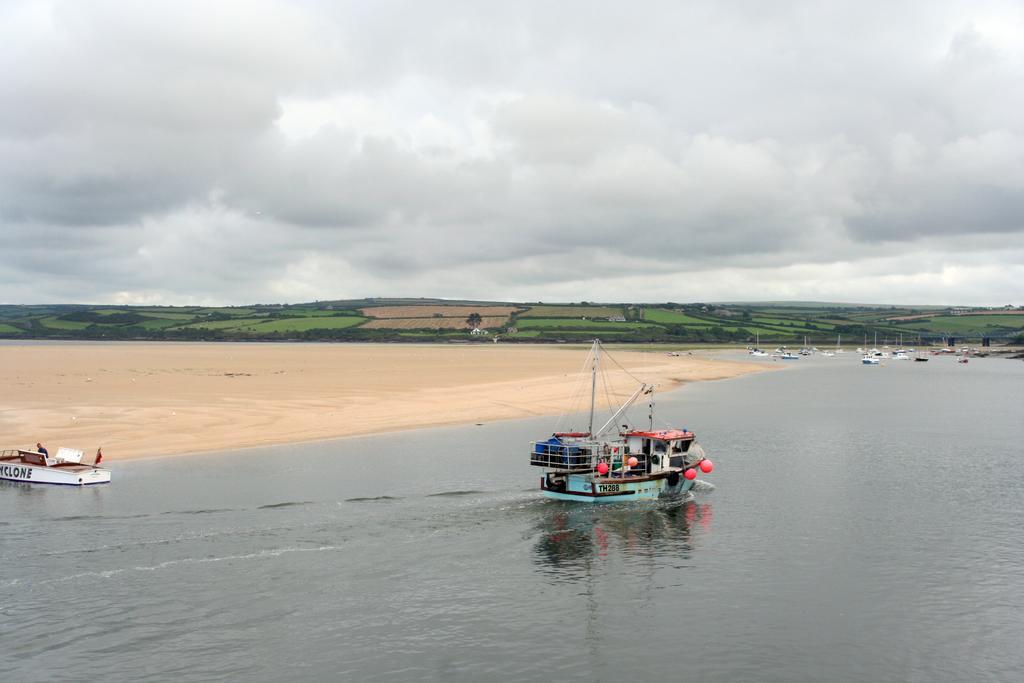Can you describe this image briefly? In this picture there are boats on the water. At the back there are fields and there are trees. At the top there is sky and there are clouds. At the bottom there is water and there is sand. 